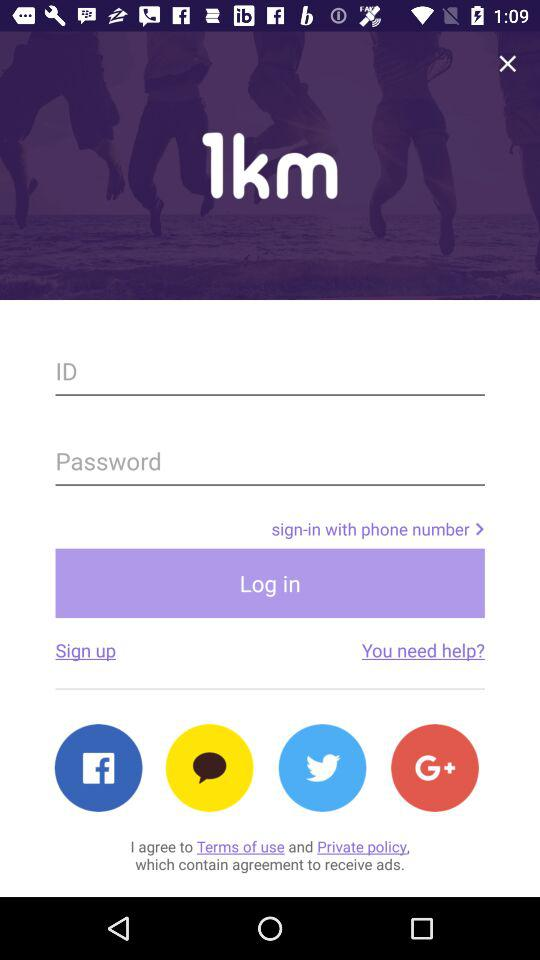Which other applications can be used to log in? The other applications that can be used to log in are "Facebook", "KakaoTalk", "Twitter" and "Google+". 